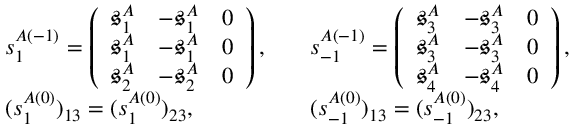<formula> <loc_0><loc_0><loc_500><loc_500>\begin{array} { r l r l } & { s _ { 1 } ^ { A ( - 1 ) } = \left ( \begin{array} { l l l } { \mathfrak { s } _ { 1 } ^ { A } } & { - \mathfrak { s } _ { 1 } ^ { A } } & { 0 } \\ { \mathfrak { s } _ { 1 } ^ { A } } & { - \mathfrak { s } _ { 1 } ^ { A } } & { 0 } \\ { \mathfrak { s } _ { 2 } ^ { A } } & { - \mathfrak { s } _ { 2 } ^ { A } } & { 0 } \end{array} \right ) , } & & { s _ { - 1 } ^ { A ( - 1 ) } = \left ( \begin{array} { l l l } { \mathfrak { s } _ { 3 } ^ { A } } & { - \mathfrak { s } _ { 3 } ^ { A } } & { 0 } \\ { \mathfrak { s } _ { 3 } ^ { A } } & { - \mathfrak { s } _ { 3 } ^ { A } } & { 0 } \\ { \mathfrak { s } _ { 4 } ^ { A } } & { - \mathfrak { s } _ { 4 } ^ { A } } & { 0 } \end{array} \right ) , } \\ & { ( s _ { 1 } ^ { A ( 0 ) } ) _ { 1 3 } = ( s _ { 1 } ^ { A ( 0 ) } ) _ { 2 3 } , } & & { ( s _ { - 1 } ^ { A ( 0 ) } ) _ { 1 3 } = ( s _ { - 1 } ^ { A ( 0 ) } ) _ { 2 3 } , } \end{array}</formula> 